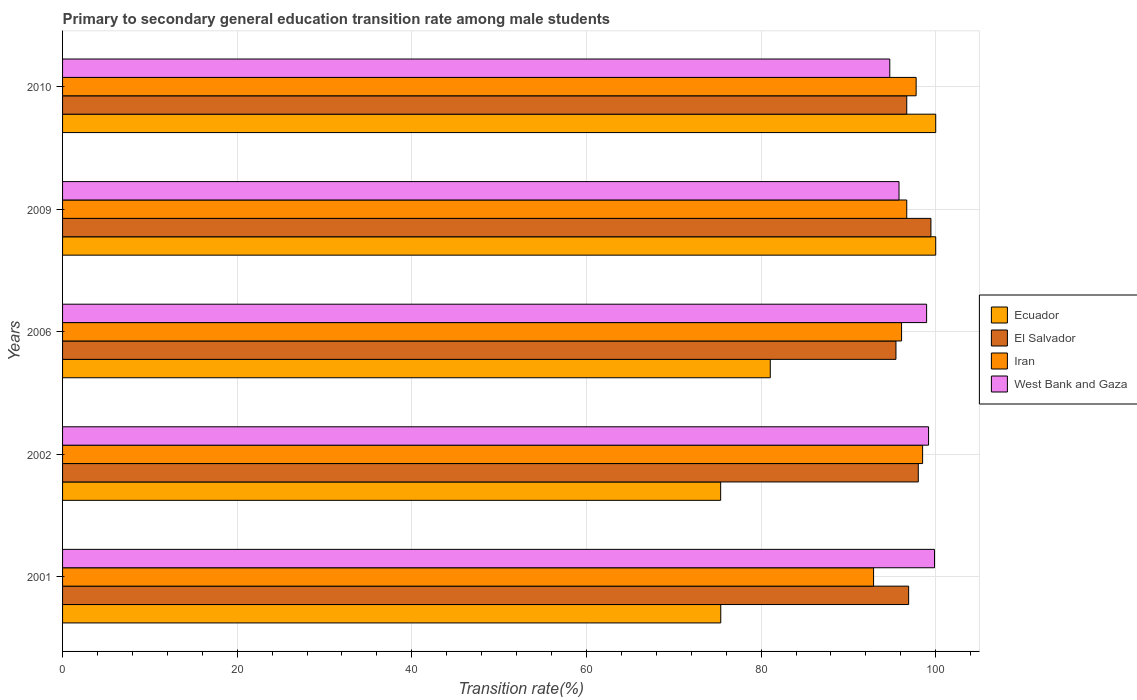How many groups of bars are there?
Give a very brief answer. 5. What is the transition rate in El Salvador in 2001?
Your answer should be very brief. 96.9. Across all years, what is the maximum transition rate in El Salvador?
Your answer should be very brief. 99.45. Across all years, what is the minimum transition rate in Ecuador?
Your answer should be compact. 75.37. In which year was the transition rate in Ecuador minimum?
Keep it short and to the point. 2002. What is the total transition rate in Iran in the graph?
Give a very brief answer. 481.91. What is the difference between the transition rate in El Salvador in 2001 and that in 2006?
Your response must be concise. 1.45. What is the difference between the transition rate in El Salvador in 2006 and the transition rate in Ecuador in 2009?
Your answer should be compact. -4.55. What is the average transition rate in El Salvador per year?
Give a very brief answer. 97.3. In the year 2010, what is the difference between the transition rate in Ecuador and transition rate in El Salvador?
Provide a succinct answer. 3.32. What is the ratio of the transition rate in Iran in 2002 to that in 2006?
Your response must be concise. 1.03. What is the difference between the highest and the second highest transition rate in Iran?
Offer a very short reply. 0.74. What is the difference between the highest and the lowest transition rate in Ecuador?
Offer a terse response. 24.63. What does the 4th bar from the top in 2001 represents?
Give a very brief answer. Ecuador. What does the 2nd bar from the bottom in 2009 represents?
Your answer should be very brief. El Salvador. Is it the case that in every year, the sum of the transition rate in Iran and transition rate in El Salvador is greater than the transition rate in West Bank and Gaza?
Provide a short and direct response. Yes. Does the graph contain grids?
Give a very brief answer. Yes. Where does the legend appear in the graph?
Keep it short and to the point. Center right. How many legend labels are there?
Provide a succinct answer. 4. How are the legend labels stacked?
Offer a terse response. Vertical. What is the title of the graph?
Your response must be concise. Primary to secondary general education transition rate among male students. What is the label or title of the X-axis?
Provide a succinct answer. Transition rate(%). What is the Transition rate(%) in Ecuador in 2001?
Provide a succinct answer. 75.38. What is the Transition rate(%) in El Salvador in 2001?
Make the answer very short. 96.9. What is the Transition rate(%) of Iran in 2001?
Your answer should be compact. 92.88. What is the Transition rate(%) in West Bank and Gaza in 2001?
Keep it short and to the point. 99.86. What is the Transition rate(%) of Ecuador in 2002?
Offer a terse response. 75.37. What is the Transition rate(%) in El Salvador in 2002?
Offer a very short reply. 98. What is the Transition rate(%) in Iran in 2002?
Your response must be concise. 98.5. What is the Transition rate(%) of West Bank and Gaza in 2002?
Provide a short and direct response. 99.18. What is the Transition rate(%) of Ecuador in 2006?
Provide a succinct answer. 81.05. What is the Transition rate(%) in El Salvador in 2006?
Keep it short and to the point. 95.45. What is the Transition rate(%) in Iran in 2006?
Give a very brief answer. 96.09. What is the Transition rate(%) in West Bank and Gaza in 2006?
Your answer should be very brief. 98.96. What is the Transition rate(%) in El Salvador in 2009?
Provide a short and direct response. 99.45. What is the Transition rate(%) in Iran in 2009?
Your answer should be compact. 96.68. What is the Transition rate(%) of West Bank and Gaza in 2009?
Provide a succinct answer. 95.8. What is the Transition rate(%) of Ecuador in 2010?
Provide a short and direct response. 100. What is the Transition rate(%) of El Salvador in 2010?
Keep it short and to the point. 96.68. What is the Transition rate(%) in Iran in 2010?
Your answer should be compact. 97.76. What is the Transition rate(%) of West Bank and Gaza in 2010?
Keep it short and to the point. 94.74. Across all years, what is the maximum Transition rate(%) in El Salvador?
Give a very brief answer. 99.45. Across all years, what is the maximum Transition rate(%) of Iran?
Give a very brief answer. 98.5. Across all years, what is the maximum Transition rate(%) of West Bank and Gaza?
Offer a very short reply. 99.86. Across all years, what is the minimum Transition rate(%) of Ecuador?
Offer a very short reply. 75.37. Across all years, what is the minimum Transition rate(%) of El Salvador?
Give a very brief answer. 95.45. Across all years, what is the minimum Transition rate(%) of Iran?
Your response must be concise. 92.88. Across all years, what is the minimum Transition rate(%) of West Bank and Gaza?
Give a very brief answer. 94.74. What is the total Transition rate(%) of Ecuador in the graph?
Make the answer very short. 431.8. What is the total Transition rate(%) in El Salvador in the graph?
Provide a succinct answer. 486.48. What is the total Transition rate(%) of Iran in the graph?
Keep it short and to the point. 481.91. What is the total Transition rate(%) of West Bank and Gaza in the graph?
Provide a short and direct response. 488.53. What is the difference between the Transition rate(%) of Ecuador in 2001 and that in 2002?
Your answer should be compact. 0.01. What is the difference between the Transition rate(%) of El Salvador in 2001 and that in 2002?
Offer a terse response. -1.1. What is the difference between the Transition rate(%) in Iran in 2001 and that in 2002?
Your response must be concise. -5.62. What is the difference between the Transition rate(%) of West Bank and Gaza in 2001 and that in 2002?
Provide a short and direct response. 0.68. What is the difference between the Transition rate(%) of Ecuador in 2001 and that in 2006?
Keep it short and to the point. -5.67. What is the difference between the Transition rate(%) in El Salvador in 2001 and that in 2006?
Give a very brief answer. 1.45. What is the difference between the Transition rate(%) of Iran in 2001 and that in 2006?
Provide a short and direct response. -3.2. What is the difference between the Transition rate(%) of West Bank and Gaza in 2001 and that in 2006?
Your response must be concise. 0.9. What is the difference between the Transition rate(%) in Ecuador in 2001 and that in 2009?
Make the answer very short. -24.62. What is the difference between the Transition rate(%) of El Salvador in 2001 and that in 2009?
Give a very brief answer. -2.55. What is the difference between the Transition rate(%) of West Bank and Gaza in 2001 and that in 2009?
Keep it short and to the point. 4.07. What is the difference between the Transition rate(%) of Ecuador in 2001 and that in 2010?
Provide a succinct answer. -24.62. What is the difference between the Transition rate(%) of El Salvador in 2001 and that in 2010?
Your answer should be compact. 0.22. What is the difference between the Transition rate(%) in Iran in 2001 and that in 2010?
Your response must be concise. -4.87. What is the difference between the Transition rate(%) in West Bank and Gaza in 2001 and that in 2010?
Your response must be concise. 5.12. What is the difference between the Transition rate(%) in Ecuador in 2002 and that in 2006?
Your answer should be compact. -5.68. What is the difference between the Transition rate(%) of El Salvador in 2002 and that in 2006?
Offer a very short reply. 2.56. What is the difference between the Transition rate(%) of Iran in 2002 and that in 2006?
Offer a terse response. 2.41. What is the difference between the Transition rate(%) of West Bank and Gaza in 2002 and that in 2006?
Provide a succinct answer. 0.22. What is the difference between the Transition rate(%) of Ecuador in 2002 and that in 2009?
Keep it short and to the point. -24.63. What is the difference between the Transition rate(%) of El Salvador in 2002 and that in 2009?
Your response must be concise. -1.45. What is the difference between the Transition rate(%) in Iran in 2002 and that in 2009?
Provide a short and direct response. 1.82. What is the difference between the Transition rate(%) in West Bank and Gaza in 2002 and that in 2009?
Your answer should be compact. 3.38. What is the difference between the Transition rate(%) of Ecuador in 2002 and that in 2010?
Your response must be concise. -24.63. What is the difference between the Transition rate(%) of El Salvador in 2002 and that in 2010?
Make the answer very short. 1.32. What is the difference between the Transition rate(%) in Iran in 2002 and that in 2010?
Your response must be concise. 0.74. What is the difference between the Transition rate(%) in West Bank and Gaza in 2002 and that in 2010?
Ensure brevity in your answer.  4.44. What is the difference between the Transition rate(%) of Ecuador in 2006 and that in 2009?
Your response must be concise. -18.95. What is the difference between the Transition rate(%) of El Salvador in 2006 and that in 2009?
Provide a short and direct response. -4. What is the difference between the Transition rate(%) in Iran in 2006 and that in 2009?
Your response must be concise. -0.6. What is the difference between the Transition rate(%) of West Bank and Gaza in 2006 and that in 2009?
Keep it short and to the point. 3.16. What is the difference between the Transition rate(%) in Ecuador in 2006 and that in 2010?
Your answer should be very brief. -18.95. What is the difference between the Transition rate(%) in El Salvador in 2006 and that in 2010?
Keep it short and to the point. -1.24. What is the difference between the Transition rate(%) in Iran in 2006 and that in 2010?
Make the answer very short. -1.67. What is the difference between the Transition rate(%) of West Bank and Gaza in 2006 and that in 2010?
Provide a succinct answer. 4.22. What is the difference between the Transition rate(%) of Ecuador in 2009 and that in 2010?
Make the answer very short. 0. What is the difference between the Transition rate(%) in El Salvador in 2009 and that in 2010?
Your answer should be very brief. 2.77. What is the difference between the Transition rate(%) of Iran in 2009 and that in 2010?
Keep it short and to the point. -1.07. What is the difference between the Transition rate(%) of West Bank and Gaza in 2009 and that in 2010?
Give a very brief answer. 1.06. What is the difference between the Transition rate(%) in Ecuador in 2001 and the Transition rate(%) in El Salvador in 2002?
Give a very brief answer. -22.62. What is the difference between the Transition rate(%) of Ecuador in 2001 and the Transition rate(%) of Iran in 2002?
Provide a succinct answer. -23.12. What is the difference between the Transition rate(%) in Ecuador in 2001 and the Transition rate(%) in West Bank and Gaza in 2002?
Provide a succinct answer. -23.8. What is the difference between the Transition rate(%) of El Salvador in 2001 and the Transition rate(%) of Iran in 2002?
Ensure brevity in your answer.  -1.6. What is the difference between the Transition rate(%) of El Salvador in 2001 and the Transition rate(%) of West Bank and Gaza in 2002?
Your answer should be compact. -2.28. What is the difference between the Transition rate(%) of Iran in 2001 and the Transition rate(%) of West Bank and Gaza in 2002?
Your answer should be compact. -6.3. What is the difference between the Transition rate(%) in Ecuador in 2001 and the Transition rate(%) in El Salvador in 2006?
Make the answer very short. -20.06. What is the difference between the Transition rate(%) in Ecuador in 2001 and the Transition rate(%) in Iran in 2006?
Keep it short and to the point. -20.71. What is the difference between the Transition rate(%) in Ecuador in 2001 and the Transition rate(%) in West Bank and Gaza in 2006?
Ensure brevity in your answer.  -23.57. What is the difference between the Transition rate(%) of El Salvador in 2001 and the Transition rate(%) of Iran in 2006?
Your answer should be compact. 0.81. What is the difference between the Transition rate(%) of El Salvador in 2001 and the Transition rate(%) of West Bank and Gaza in 2006?
Give a very brief answer. -2.06. What is the difference between the Transition rate(%) of Iran in 2001 and the Transition rate(%) of West Bank and Gaza in 2006?
Your response must be concise. -6.07. What is the difference between the Transition rate(%) in Ecuador in 2001 and the Transition rate(%) in El Salvador in 2009?
Ensure brevity in your answer.  -24.07. What is the difference between the Transition rate(%) in Ecuador in 2001 and the Transition rate(%) in Iran in 2009?
Provide a succinct answer. -21.3. What is the difference between the Transition rate(%) of Ecuador in 2001 and the Transition rate(%) of West Bank and Gaza in 2009?
Your answer should be compact. -20.41. What is the difference between the Transition rate(%) of El Salvador in 2001 and the Transition rate(%) of Iran in 2009?
Provide a short and direct response. 0.22. What is the difference between the Transition rate(%) of El Salvador in 2001 and the Transition rate(%) of West Bank and Gaza in 2009?
Your answer should be very brief. 1.1. What is the difference between the Transition rate(%) of Iran in 2001 and the Transition rate(%) of West Bank and Gaza in 2009?
Make the answer very short. -2.91. What is the difference between the Transition rate(%) in Ecuador in 2001 and the Transition rate(%) in El Salvador in 2010?
Your response must be concise. -21.3. What is the difference between the Transition rate(%) of Ecuador in 2001 and the Transition rate(%) of Iran in 2010?
Provide a short and direct response. -22.38. What is the difference between the Transition rate(%) of Ecuador in 2001 and the Transition rate(%) of West Bank and Gaza in 2010?
Keep it short and to the point. -19.36. What is the difference between the Transition rate(%) of El Salvador in 2001 and the Transition rate(%) of Iran in 2010?
Ensure brevity in your answer.  -0.86. What is the difference between the Transition rate(%) of El Salvador in 2001 and the Transition rate(%) of West Bank and Gaza in 2010?
Make the answer very short. 2.16. What is the difference between the Transition rate(%) in Iran in 2001 and the Transition rate(%) in West Bank and Gaza in 2010?
Give a very brief answer. -1.86. What is the difference between the Transition rate(%) in Ecuador in 2002 and the Transition rate(%) in El Salvador in 2006?
Make the answer very short. -20.08. What is the difference between the Transition rate(%) in Ecuador in 2002 and the Transition rate(%) in Iran in 2006?
Your answer should be very brief. -20.72. What is the difference between the Transition rate(%) of Ecuador in 2002 and the Transition rate(%) of West Bank and Gaza in 2006?
Offer a terse response. -23.59. What is the difference between the Transition rate(%) in El Salvador in 2002 and the Transition rate(%) in Iran in 2006?
Make the answer very short. 1.92. What is the difference between the Transition rate(%) in El Salvador in 2002 and the Transition rate(%) in West Bank and Gaza in 2006?
Provide a succinct answer. -0.95. What is the difference between the Transition rate(%) in Iran in 2002 and the Transition rate(%) in West Bank and Gaza in 2006?
Your answer should be compact. -0.46. What is the difference between the Transition rate(%) in Ecuador in 2002 and the Transition rate(%) in El Salvador in 2009?
Your response must be concise. -24.08. What is the difference between the Transition rate(%) of Ecuador in 2002 and the Transition rate(%) of Iran in 2009?
Provide a short and direct response. -21.31. What is the difference between the Transition rate(%) in Ecuador in 2002 and the Transition rate(%) in West Bank and Gaza in 2009?
Give a very brief answer. -20.43. What is the difference between the Transition rate(%) in El Salvador in 2002 and the Transition rate(%) in Iran in 2009?
Give a very brief answer. 1.32. What is the difference between the Transition rate(%) of El Salvador in 2002 and the Transition rate(%) of West Bank and Gaza in 2009?
Keep it short and to the point. 2.21. What is the difference between the Transition rate(%) of Iran in 2002 and the Transition rate(%) of West Bank and Gaza in 2009?
Your response must be concise. 2.7. What is the difference between the Transition rate(%) of Ecuador in 2002 and the Transition rate(%) of El Salvador in 2010?
Your answer should be very brief. -21.31. What is the difference between the Transition rate(%) of Ecuador in 2002 and the Transition rate(%) of Iran in 2010?
Provide a succinct answer. -22.39. What is the difference between the Transition rate(%) in Ecuador in 2002 and the Transition rate(%) in West Bank and Gaza in 2010?
Make the answer very short. -19.37. What is the difference between the Transition rate(%) of El Salvador in 2002 and the Transition rate(%) of Iran in 2010?
Provide a succinct answer. 0.25. What is the difference between the Transition rate(%) in El Salvador in 2002 and the Transition rate(%) in West Bank and Gaza in 2010?
Ensure brevity in your answer.  3.27. What is the difference between the Transition rate(%) in Iran in 2002 and the Transition rate(%) in West Bank and Gaza in 2010?
Your answer should be very brief. 3.76. What is the difference between the Transition rate(%) of Ecuador in 2006 and the Transition rate(%) of El Salvador in 2009?
Your response must be concise. -18.4. What is the difference between the Transition rate(%) in Ecuador in 2006 and the Transition rate(%) in Iran in 2009?
Your answer should be very brief. -15.63. What is the difference between the Transition rate(%) of Ecuador in 2006 and the Transition rate(%) of West Bank and Gaza in 2009?
Provide a succinct answer. -14.74. What is the difference between the Transition rate(%) of El Salvador in 2006 and the Transition rate(%) of Iran in 2009?
Provide a short and direct response. -1.24. What is the difference between the Transition rate(%) of El Salvador in 2006 and the Transition rate(%) of West Bank and Gaza in 2009?
Provide a short and direct response. -0.35. What is the difference between the Transition rate(%) in Iran in 2006 and the Transition rate(%) in West Bank and Gaza in 2009?
Keep it short and to the point. 0.29. What is the difference between the Transition rate(%) of Ecuador in 2006 and the Transition rate(%) of El Salvador in 2010?
Your answer should be compact. -15.63. What is the difference between the Transition rate(%) in Ecuador in 2006 and the Transition rate(%) in Iran in 2010?
Keep it short and to the point. -16.71. What is the difference between the Transition rate(%) in Ecuador in 2006 and the Transition rate(%) in West Bank and Gaza in 2010?
Your answer should be very brief. -13.69. What is the difference between the Transition rate(%) in El Salvador in 2006 and the Transition rate(%) in Iran in 2010?
Offer a very short reply. -2.31. What is the difference between the Transition rate(%) in El Salvador in 2006 and the Transition rate(%) in West Bank and Gaza in 2010?
Offer a terse response. 0.71. What is the difference between the Transition rate(%) in Iran in 2006 and the Transition rate(%) in West Bank and Gaza in 2010?
Your answer should be very brief. 1.35. What is the difference between the Transition rate(%) of Ecuador in 2009 and the Transition rate(%) of El Salvador in 2010?
Provide a succinct answer. 3.32. What is the difference between the Transition rate(%) of Ecuador in 2009 and the Transition rate(%) of Iran in 2010?
Your answer should be compact. 2.24. What is the difference between the Transition rate(%) of Ecuador in 2009 and the Transition rate(%) of West Bank and Gaza in 2010?
Offer a very short reply. 5.26. What is the difference between the Transition rate(%) in El Salvador in 2009 and the Transition rate(%) in Iran in 2010?
Offer a terse response. 1.69. What is the difference between the Transition rate(%) in El Salvador in 2009 and the Transition rate(%) in West Bank and Gaza in 2010?
Make the answer very short. 4.71. What is the difference between the Transition rate(%) in Iran in 2009 and the Transition rate(%) in West Bank and Gaza in 2010?
Offer a very short reply. 1.94. What is the average Transition rate(%) of Ecuador per year?
Your answer should be very brief. 86.36. What is the average Transition rate(%) in El Salvador per year?
Offer a terse response. 97.3. What is the average Transition rate(%) of Iran per year?
Your answer should be very brief. 96.38. What is the average Transition rate(%) of West Bank and Gaza per year?
Provide a succinct answer. 97.71. In the year 2001, what is the difference between the Transition rate(%) in Ecuador and Transition rate(%) in El Salvador?
Offer a terse response. -21.52. In the year 2001, what is the difference between the Transition rate(%) of Ecuador and Transition rate(%) of Iran?
Your answer should be compact. -17.5. In the year 2001, what is the difference between the Transition rate(%) in Ecuador and Transition rate(%) in West Bank and Gaza?
Make the answer very short. -24.48. In the year 2001, what is the difference between the Transition rate(%) of El Salvador and Transition rate(%) of Iran?
Your answer should be compact. 4.02. In the year 2001, what is the difference between the Transition rate(%) in El Salvador and Transition rate(%) in West Bank and Gaza?
Ensure brevity in your answer.  -2.96. In the year 2001, what is the difference between the Transition rate(%) of Iran and Transition rate(%) of West Bank and Gaza?
Provide a succinct answer. -6.98. In the year 2002, what is the difference between the Transition rate(%) of Ecuador and Transition rate(%) of El Salvador?
Ensure brevity in your answer.  -22.63. In the year 2002, what is the difference between the Transition rate(%) of Ecuador and Transition rate(%) of Iran?
Your response must be concise. -23.13. In the year 2002, what is the difference between the Transition rate(%) in Ecuador and Transition rate(%) in West Bank and Gaza?
Offer a terse response. -23.81. In the year 2002, what is the difference between the Transition rate(%) of El Salvador and Transition rate(%) of Iran?
Your answer should be compact. -0.5. In the year 2002, what is the difference between the Transition rate(%) in El Salvador and Transition rate(%) in West Bank and Gaza?
Provide a short and direct response. -1.18. In the year 2002, what is the difference between the Transition rate(%) in Iran and Transition rate(%) in West Bank and Gaza?
Your response must be concise. -0.68. In the year 2006, what is the difference between the Transition rate(%) in Ecuador and Transition rate(%) in El Salvador?
Make the answer very short. -14.39. In the year 2006, what is the difference between the Transition rate(%) of Ecuador and Transition rate(%) of Iran?
Keep it short and to the point. -15.04. In the year 2006, what is the difference between the Transition rate(%) in Ecuador and Transition rate(%) in West Bank and Gaza?
Give a very brief answer. -17.9. In the year 2006, what is the difference between the Transition rate(%) of El Salvador and Transition rate(%) of Iran?
Provide a succinct answer. -0.64. In the year 2006, what is the difference between the Transition rate(%) of El Salvador and Transition rate(%) of West Bank and Gaza?
Keep it short and to the point. -3.51. In the year 2006, what is the difference between the Transition rate(%) of Iran and Transition rate(%) of West Bank and Gaza?
Ensure brevity in your answer.  -2.87. In the year 2009, what is the difference between the Transition rate(%) in Ecuador and Transition rate(%) in El Salvador?
Keep it short and to the point. 0.55. In the year 2009, what is the difference between the Transition rate(%) of Ecuador and Transition rate(%) of Iran?
Your answer should be very brief. 3.32. In the year 2009, what is the difference between the Transition rate(%) in Ecuador and Transition rate(%) in West Bank and Gaza?
Give a very brief answer. 4.2. In the year 2009, what is the difference between the Transition rate(%) of El Salvador and Transition rate(%) of Iran?
Give a very brief answer. 2.77. In the year 2009, what is the difference between the Transition rate(%) in El Salvador and Transition rate(%) in West Bank and Gaza?
Keep it short and to the point. 3.65. In the year 2009, what is the difference between the Transition rate(%) of Iran and Transition rate(%) of West Bank and Gaza?
Your answer should be compact. 0.89. In the year 2010, what is the difference between the Transition rate(%) in Ecuador and Transition rate(%) in El Salvador?
Make the answer very short. 3.32. In the year 2010, what is the difference between the Transition rate(%) of Ecuador and Transition rate(%) of Iran?
Ensure brevity in your answer.  2.24. In the year 2010, what is the difference between the Transition rate(%) in Ecuador and Transition rate(%) in West Bank and Gaza?
Your answer should be very brief. 5.26. In the year 2010, what is the difference between the Transition rate(%) in El Salvador and Transition rate(%) in Iran?
Offer a very short reply. -1.07. In the year 2010, what is the difference between the Transition rate(%) in El Salvador and Transition rate(%) in West Bank and Gaza?
Offer a terse response. 1.94. In the year 2010, what is the difference between the Transition rate(%) in Iran and Transition rate(%) in West Bank and Gaza?
Offer a terse response. 3.02. What is the ratio of the Transition rate(%) in Ecuador in 2001 to that in 2002?
Give a very brief answer. 1. What is the ratio of the Transition rate(%) in El Salvador in 2001 to that in 2002?
Your response must be concise. 0.99. What is the ratio of the Transition rate(%) of Iran in 2001 to that in 2002?
Provide a short and direct response. 0.94. What is the ratio of the Transition rate(%) of West Bank and Gaza in 2001 to that in 2002?
Give a very brief answer. 1.01. What is the ratio of the Transition rate(%) of El Salvador in 2001 to that in 2006?
Provide a short and direct response. 1.02. What is the ratio of the Transition rate(%) of Iran in 2001 to that in 2006?
Your answer should be compact. 0.97. What is the ratio of the Transition rate(%) of West Bank and Gaza in 2001 to that in 2006?
Offer a very short reply. 1.01. What is the ratio of the Transition rate(%) in Ecuador in 2001 to that in 2009?
Your answer should be compact. 0.75. What is the ratio of the Transition rate(%) of El Salvador in 2001 to that in 2009?
Offer a terse response. 0.97. What is the ratio of the Transition rate(%) of Iran in 2001 to that in 2009?
Offer a terse response. 0.96. What is the ratio of the Transition rate(%) of West Bank and Gaza in 2001 to that in 2009?
Give a very brief answer. 1.04. What is the ratio of the Transition rate(%) of Ecuador in 2001 to that in 2010?
Give a very brief answer. 0.75. What is the ratio of the Transition rate(%) in Iran in 2001 to that in 2010?
Keep it short and to the point. 0.95. What is the ratio of the Transition rate(%) of West Bank and Gaza in 2001 to that in 2010?
Offer a very short reply. 1.05. What is the ratio of the Transition rate(%) in Ecuador in 2002 to that in 2006?
Make the answer very short. 0.93. What is the ratio of the Transition rate(%) in El Salvador in 2002 to that in 2006?
Offer a very short reply. 1.03. What is the ratio of the Transition rate(%) of Iran in 2002 to that in 2006?
Your response must be concise. 1.03. What is the ratio of the Transition rate(%) of West Bank and Gaza in 2002 to that in 2006?
Offer a very short reply. 1. What is the ratio of the Transition rate(%) of Ecuador in 2002 to that in 2009?
Offer a terse response. 0.75. What is the ratio of the Transition rate(%) in El Salvador in 2002 to that in 2009?
Provide a short and direct response. 0.99. What is the ratio of the Transition rate(%) of Iran in 2002 to that in 2009?
Your response must be concise. 1.02. What is the ratio of the Transition rate(%) of West Bank and Gaza in 2002 to that in 2009?
Your answer should be very brief. 1.04. What is the ratio of the Transition rate(%) in Ecuador in 2002 to that in 2010?
Keep it short and to the point. 0.75. What is the ratio of the Transition rate(%) of El Salvador in 2002 to that in 2010?
Ensure brevity in your answer.  1.01. What is the ratio of the Transition rate(%) of Iran in 2002 to that in 2010?
Your answer should be compact. 1.01. What is the ratio of the Transition rate(%) in West Bank and Gaza in 2002 to that in 2010?
Keep it short and to the point. 1.05. What is the ratio of the Transition rate(%) of Ecuador in 2006 to that in 2009?
Offer a very short reply. 0.81. What is the ratio of the Transition rate(%) of El Salvador in 2006 to that in 2009?
Offer a terse response. 0.96. What is the ratio of the Transition rate(%) in Iran in 2006 to that in 2009?
Give a very brief answer. 0.99. What is the ratio of the Transition rate(%) of West Bank and Gaza in 2006 to that in 2009?
Your answer should be compact. 1.03. What is the ratio of the Transition rate(%) in Ecuador in 2006 to that in 2010?
Offer a terse response. 0.81. What is the ratio of the Transition rate(%) in El Salvador in 2006 to that in 2010?
Keep it short and to the point. 0.99. What is the ratio of the Transition rate(%) of Iran in 2006 to that in 2010?
Offer a very short reply. 0.98. What is the ratio of the Transition rate(%) of West Bank and Gaza in 2006 to that in 2010?
Ensure brevity in your answer.  1.04. What is the ratio of the Transition rate(%) of Ecuador in 2009 to that in 2010?
Your answer should be compact. 1. What is the ratio of the Transition rate(%) of El Salvador in 2009 to that in 2010?
Your response must be concise. 1.03. What is the ratio of the Transition rate(%) of West Bank and Gaza in 2009 to that in 2010?
Offer a terse response. 1.01. What is the difference between the highest and the second highest Transition rate(%) in Ecuador?
Offer a very short reply. 0. What is the difference between the highest and the second highest Transition rate(%) in El Salvador?
Make the answer very short. 1.45. What is the difference between the highest and the second highest Transition rate(%) in Iran?
Offer a terse response. 0.74. What is the difference between the highest and the second highest Transition rate(%) in West Bank and Gaza?
Provide a succinct answer. 0.68. What is the difference between the highest and the lowest Transition rate(%) in Ecuador?
Keep it short and to the point. 24.63. What is the difference between the highest and the lowest Transition rate(%) in El Salvador?
Give a very brief answer. 4. What is the difference between the highest and the lowest Transition rate(%) of Iran?
Your answer should be very brief. 5.62. What is the difference between the highest and the lowest Transition rate(%) in West Bank and Gaza?
Make the answer very short. 5.12. 